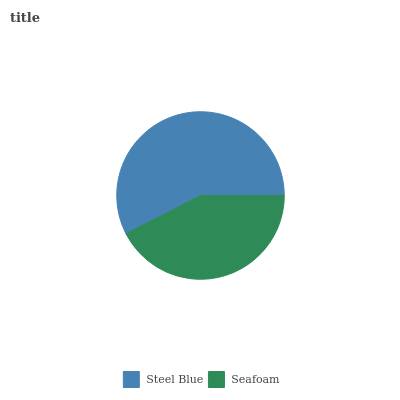Is Seafoam the minimum?
Answer yes or no. Yes. Is Steel Blue the maximum?
Answer yes or no. Yes. Is Seafoam the maximum?
Answer yes or no. No. Is Steel Blue greater than Seafoam?
Answer yes or no. Yes. Is Seafoam less than Steel Blue?
Answer yes or no. Yes. Is Seafoam greater than Steel Blue?
Answer yes or no. No. Is Steel Blue less than Seafoam?
Answer yes or no. No. Is Steel Blue the high median?
Answer yes or no. Yes. Is Seafoam the low median?
Answer yes or no. Yes. Is Seafoam the high median?
Answer yes or no. No. Is Steel Blue the low median?
Answer yes or no. No. 